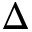<formula> <loc_0><loc_0><loc_500><loc_500>\Delta</formula> 